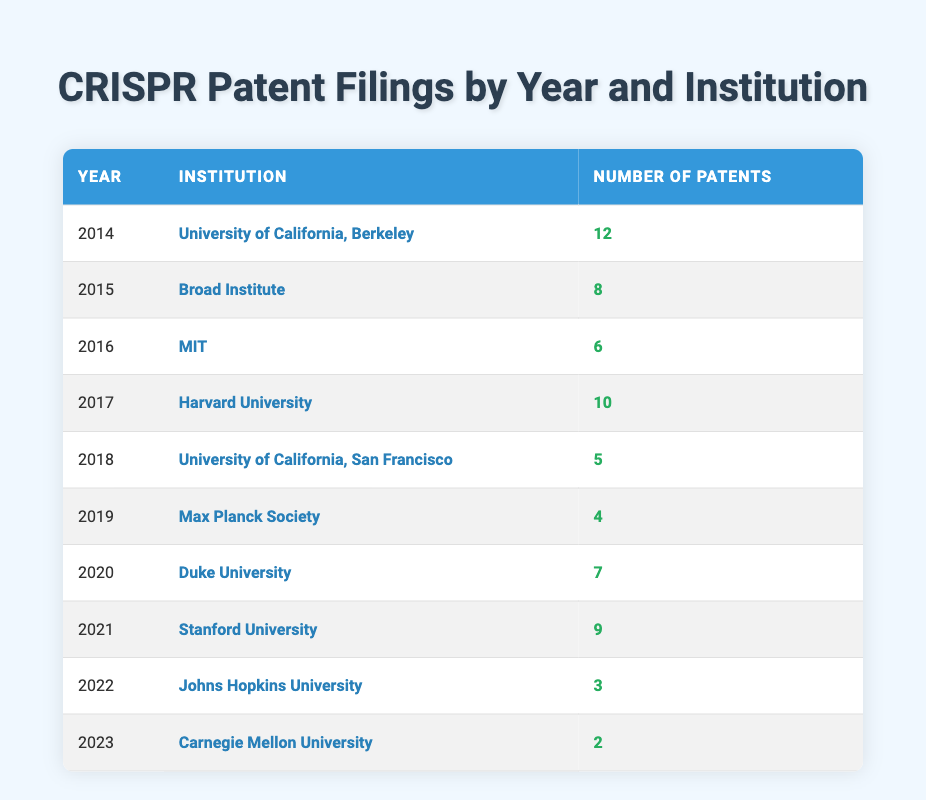What institution filed the most patents in 2014? In 2014, the University of California, Berkeley filed 12 patents, which is the highest number for that year. There are no other institutions listed for that year with a higher count.
Answer: University of California, Berkeley How many patents did Broad Institute file in 2015? The table shows that in 2015, the Broad Institute filed 8 patents, which is explicitly stated.
Answer: 8 What is the total number of patents filed by MIT from 2016 to 2018? Adding the patents filed by MIT (6 in 2016), University of California, San Francisco (5 in 2018), and no patents in 2017 means the total is 6 + 0 + 5 = 11.
Answer: 11 Did Johns Hopkins University file more than 5 patents in 2022? In 2022, Johns Hopkins University filed 3 patents, which is less than 5. This can be directly observed in the table.
Answer: No Which year had the highest number of patent filings and what was that number? The table indicates that 2014 had the highest number of patent filings with 12 patents filed by the University of California, Berkeley. This is confirmed by checking each year's counts.
Answer: 12 What is the difference in the number of patents filed by Harvard University in 2017 and Carnegie Mellon University in 2023? Harvard University filed 10 patents in 2017 while Carnegie Mellon University filed 2 patents in 2023. The difference is 10 - 2 = 8.
Answer: 8 What was the average number of patents filed per year from 2014 to 2019? Summing the patents from 2014 to 2019 gives us 12 + 8 + 6 + 10 + 5 + 4 = 45. Since there are 6 years, the average is 45 / 6 = 7.5.
Answer: 7.5 Did any single institution file patents in every year from 2014 to 2023? Reviewing the table shows that no institution is listed for all 10 years; institutions filed patents in selective years. Therefore, the answer is based on examining the entries year by year.
Answer: No In which year did Duke University file their patents and how many did they file? According to the table, Duke University filed their patents in 2020, with a total of 7 patents. This information is directly available under the respective year and institution.
Answer: 2020, 7 